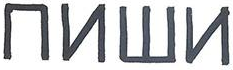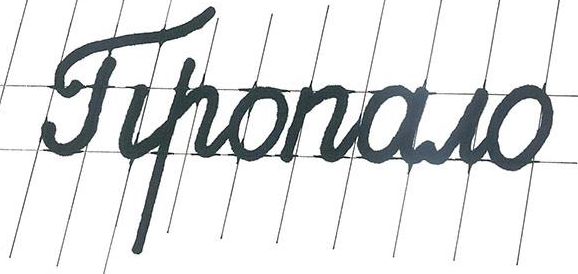Read the text content from these images in order, separated by a semicolon. ##W#; Tiponowo 